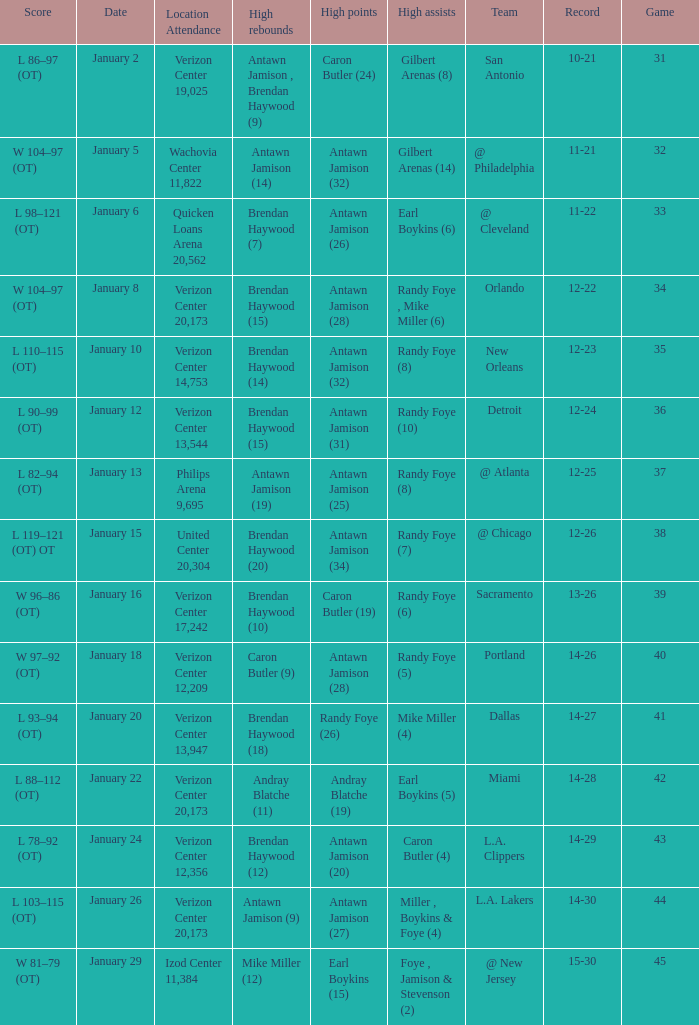How many people got high points in game 35? 1.0. 